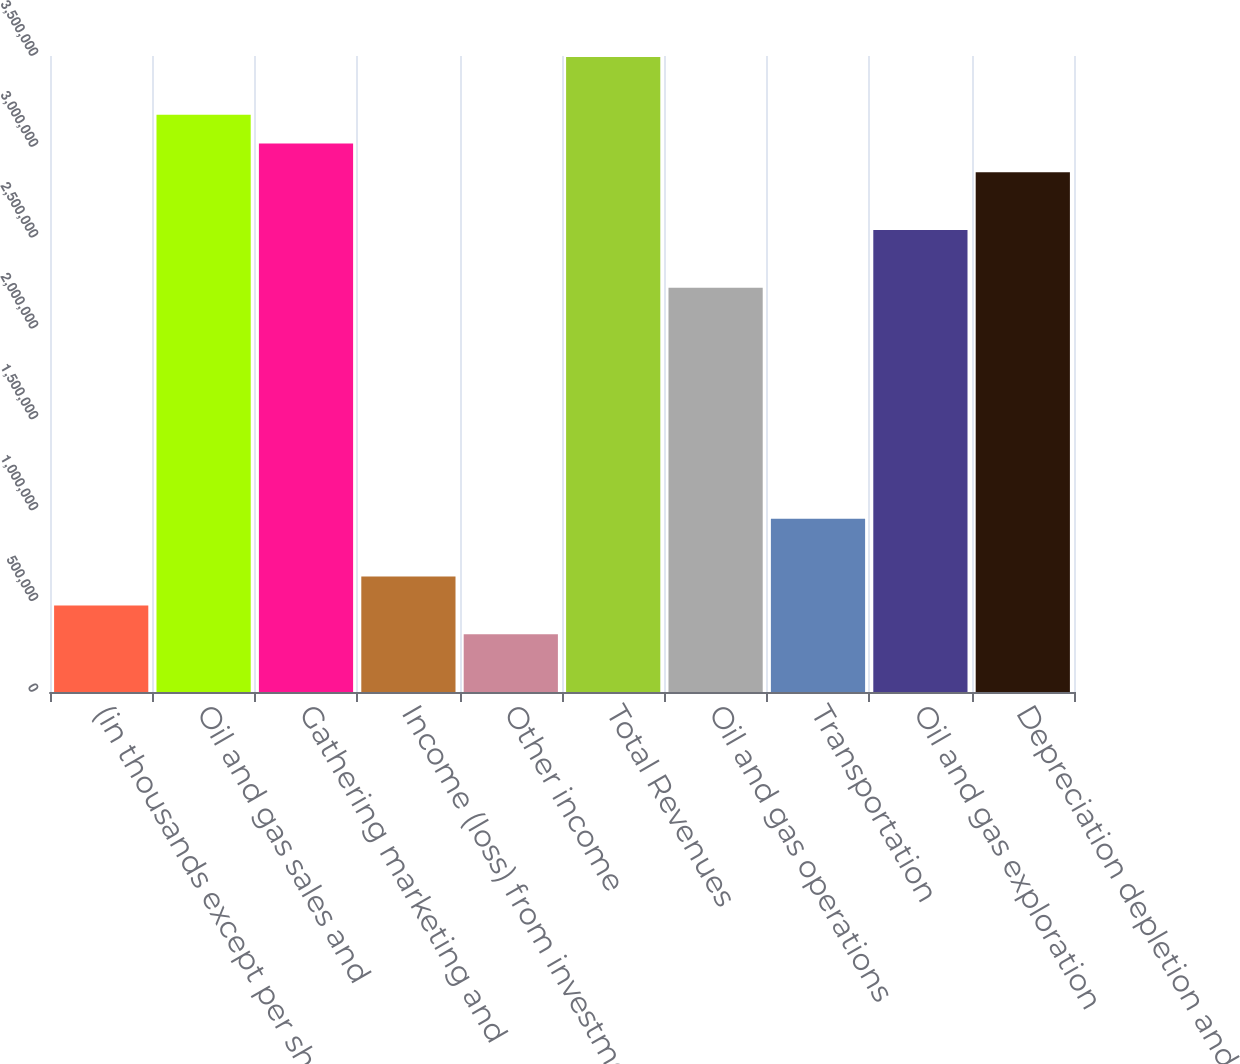Convert chart. <chart><loc_0><loc_0><loc_500><loc_500><bar_chart><fcel>(in thousands except per share<fcel>Oil and gas sales and<fcel>Gathering marketing and<fcel>Income (loss) from investment<fcel>Other income<fcel>Total Revenues<fcel>Oil and gas operations<fcel>Transportation<fcel>Oil and gas exploration<fcel>Depreciation depletion and<nl><fcel>476609<fcel>3.17738e+06<fcel>3.01851e+06<fcel>635477<fcel>317740<fcel>3.49512e+06<fcel>2.22417e+06<fcel>953215<fcel>2.5419e+06<fcel>2.85964e+06<nl></chart> 